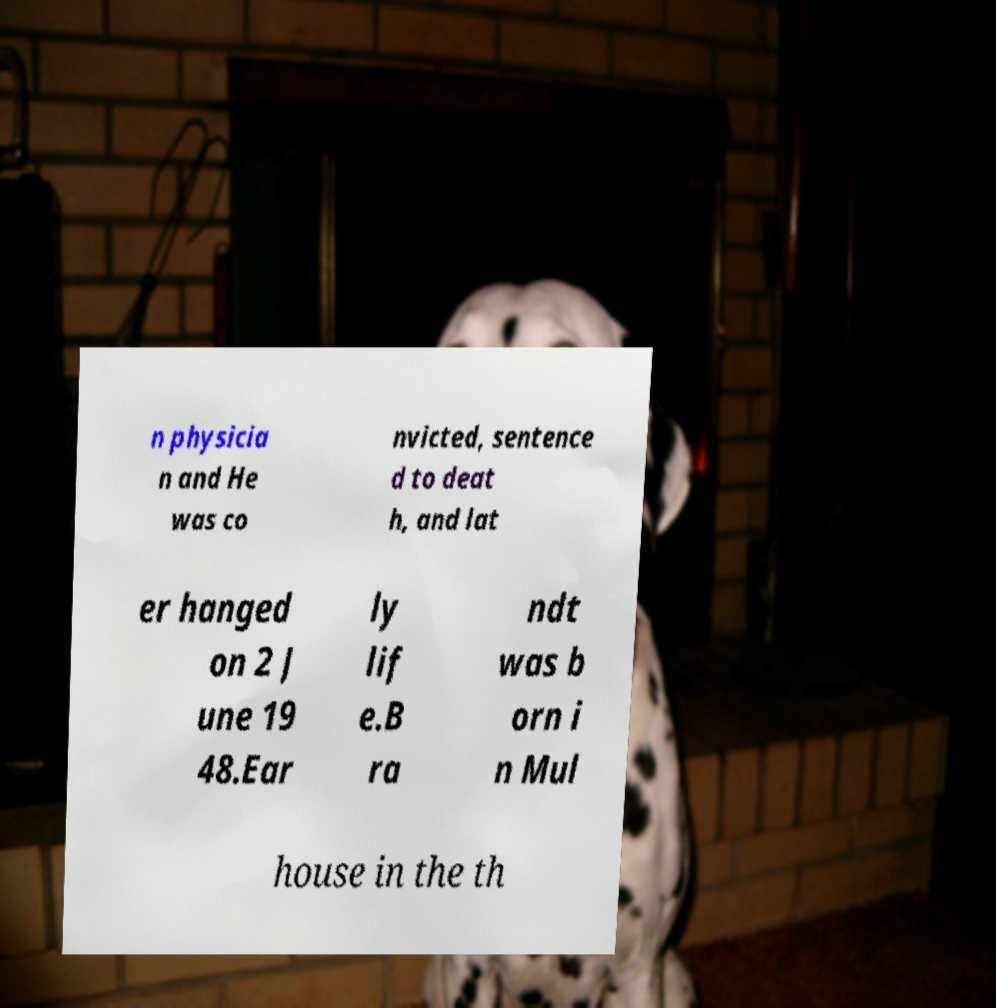Could you extract and type out the text from this image? n physicia n and He was co nvicted, sentence d to deat h, and lat er hanged on 2 J une 19 48.Ear ly lif e.B ra ndt was b orn i n Mul house in the th 